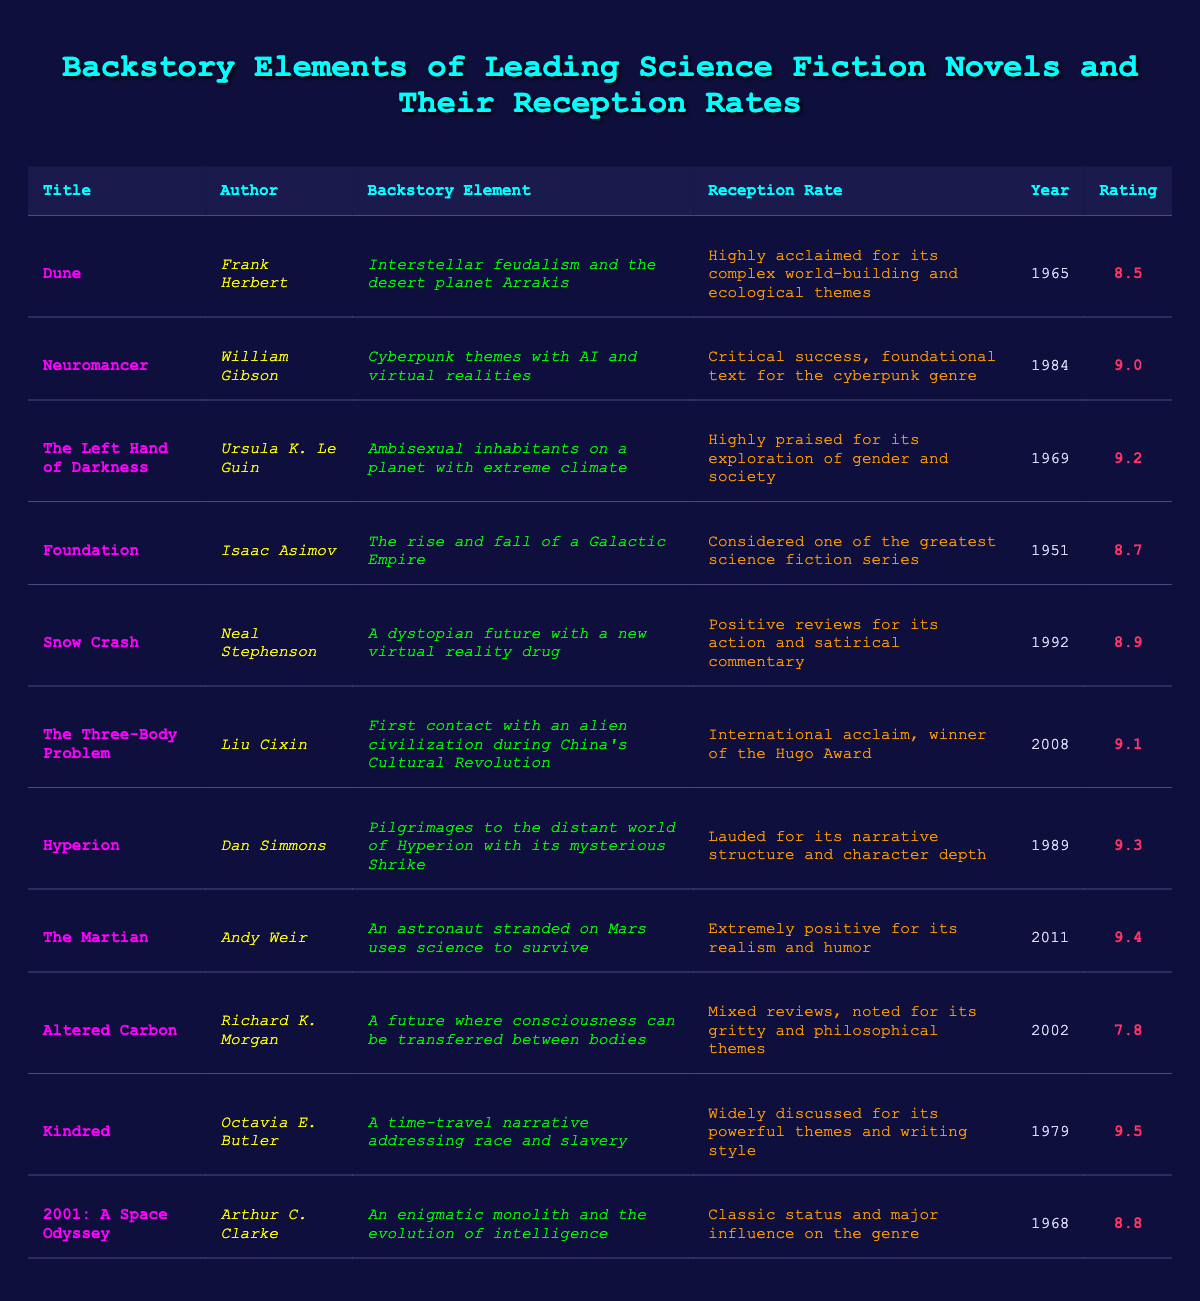What is the title of the book with the highest audience rating? To find the title with the highest audience rating, I check the "Rating" column. The highest rating listed is 9.5 for "Kindred." Therefore, the title is "Kindred."
Answer: Kindred Who is the author of "The Left Hand of Darkness"? The author is listed under the "Author" column next to "The Left Hand of Darkness." That name is Ursula K. Le Guin.
Answer: Ursula K. Le Guin What year was "Neuromancer" released? I refer to the "Year" column associated with the title "Neuromancer," which reveals it was released in 1984.
Answer: 1984 Which book was published most recently, and what is its reception rate? To find the most recently published book, I look for the highest year in the "Year" column. The latest is 2011 for "The Martian." Its reception rate is "Extremely positive for its realism and humor."
Answer: The Martian, Extremely positive for its realism and humor Is "Dune" rated higher than "Foundation"? I compare the audience ratings: "Dune" has 8.5, and "Foundation" has 8.7. Since 8.5 is less than 8.7, "Dune" is not rated higher than "Foundation."
Answer: No What is the average audience rating of the novels in the table? I will first sum the ratings: (8.5 + 9.0 + 9.2 + 8.7 + 8.9 + 9.1 + 9.3 + 9.4 + 7.8 + 9.5 + 8.8) =  105.8. There are 11 novels listed, so the average is 105.8/11 ≈ 9.6.
Answer: Approximately 9.6 Which novel addresses themes of time travel and race? The table shows that "Kindred" includes a time-travel narrative addressing race and slavery.
Answer: Kindred How many books feature a year of publication before 1970? I count the entries with years before 1970: "Foundation" (1951), "Dune" (1965), "The Left Hand of Darkness" (1969), and "2001: A Space Odyssey" (1968). This totals four books.
Answer: 4 Can you name a book that received mixed reviews, and what was its audience rating? I look for a book with "mixed reviews" in the reception rate, which corresponds to "Altered Carbon." Its audience rating is 7.8.
Answer: Altered Carbon, 7.8 How many novels have a reception rated as "Highly acclaimed"? I check the "Reception Rate" column for any entries indicating "Highly acclaimed." These are "Dune," "The Left Hand of Darkness," and "The Martian," totaling three novels.
Answer: 3 What is the difference in audience rating between "The Martian" and "Altered Carbon"? I subtract the ratings: 9.4 (The Martian) - 7.8 (Altered Carbon) = 1.6. Thus, the difference is 1.6.
Answer: 1.6 